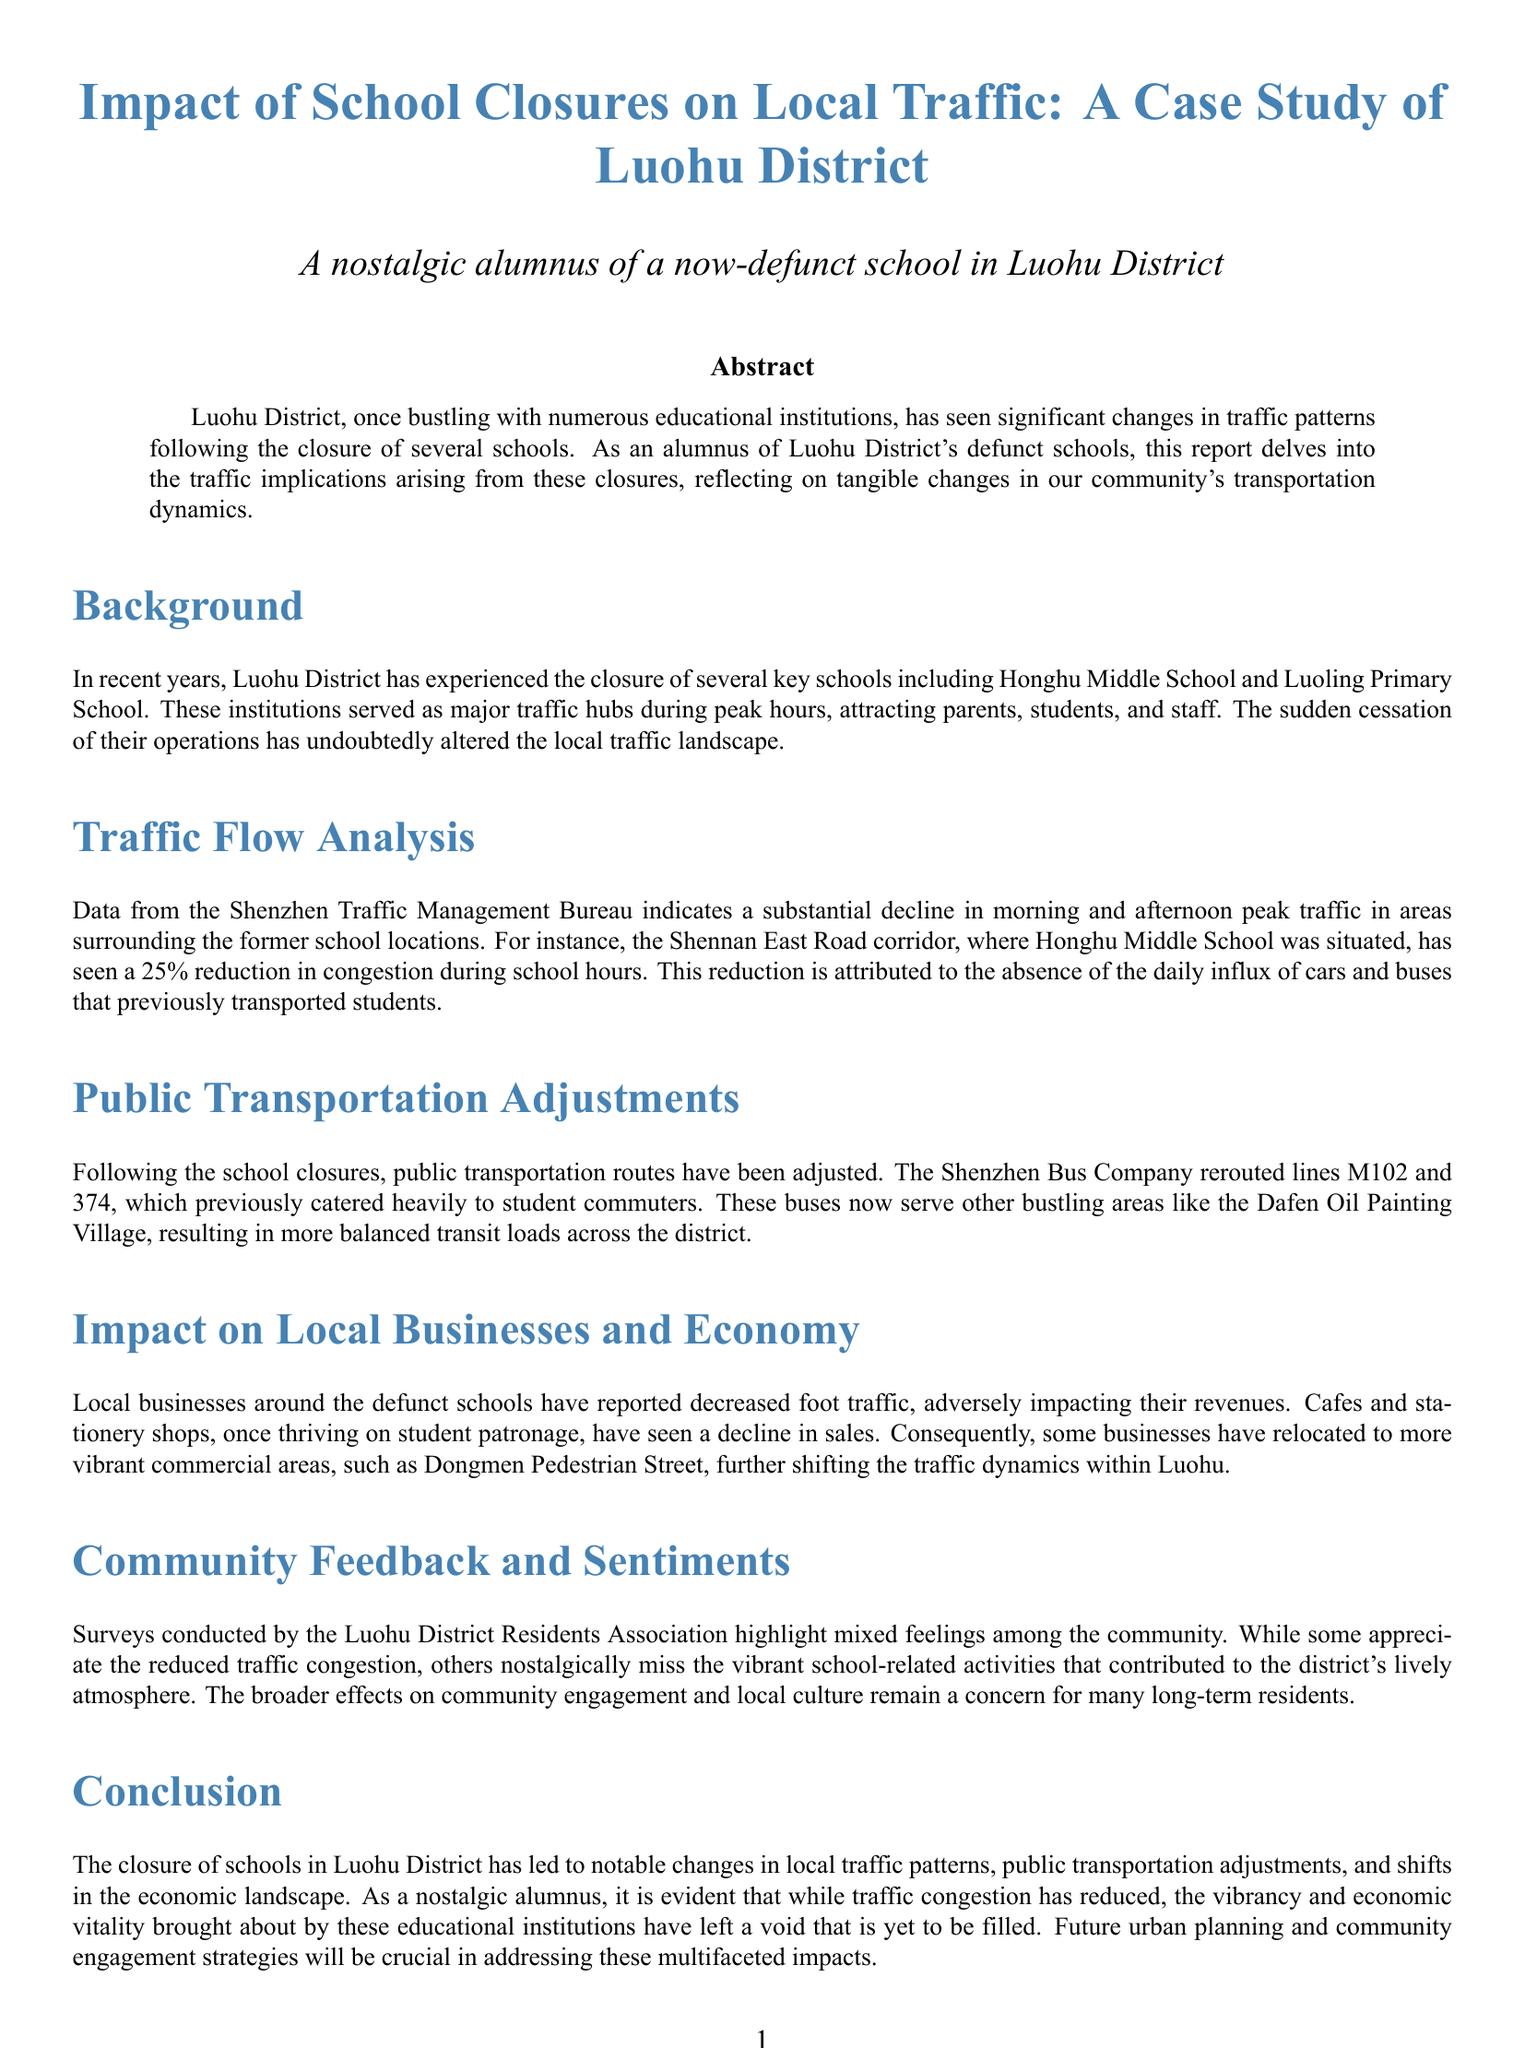What is the significant reduction in congestion during school hours? The document states that there has been a 25% reduction in congestion during school hours.
Answer: 25% Which schools were mentioned as having closed? The report mentions Honghu Middle School and Luoling Primary School as key schools that have closed.
Answer: Honghu Middle School and Luoling Primary School What public transportation lines were rerouted? The Shenzhen Bus Company rerouted lines M102 and 374 following the school closures.
Answer: M102 and 374 What was the impact on local businesses around defunct schools? Local businesses reported decreased foot traffic, adversely affecting their revenues.
Answer: Decreased foot traffic How do community members feel about school closures? Surveys highlighted mixed feelings, with some appreciating reduced congestion and others missing school-related activities.
Answer: Mixed feelings 